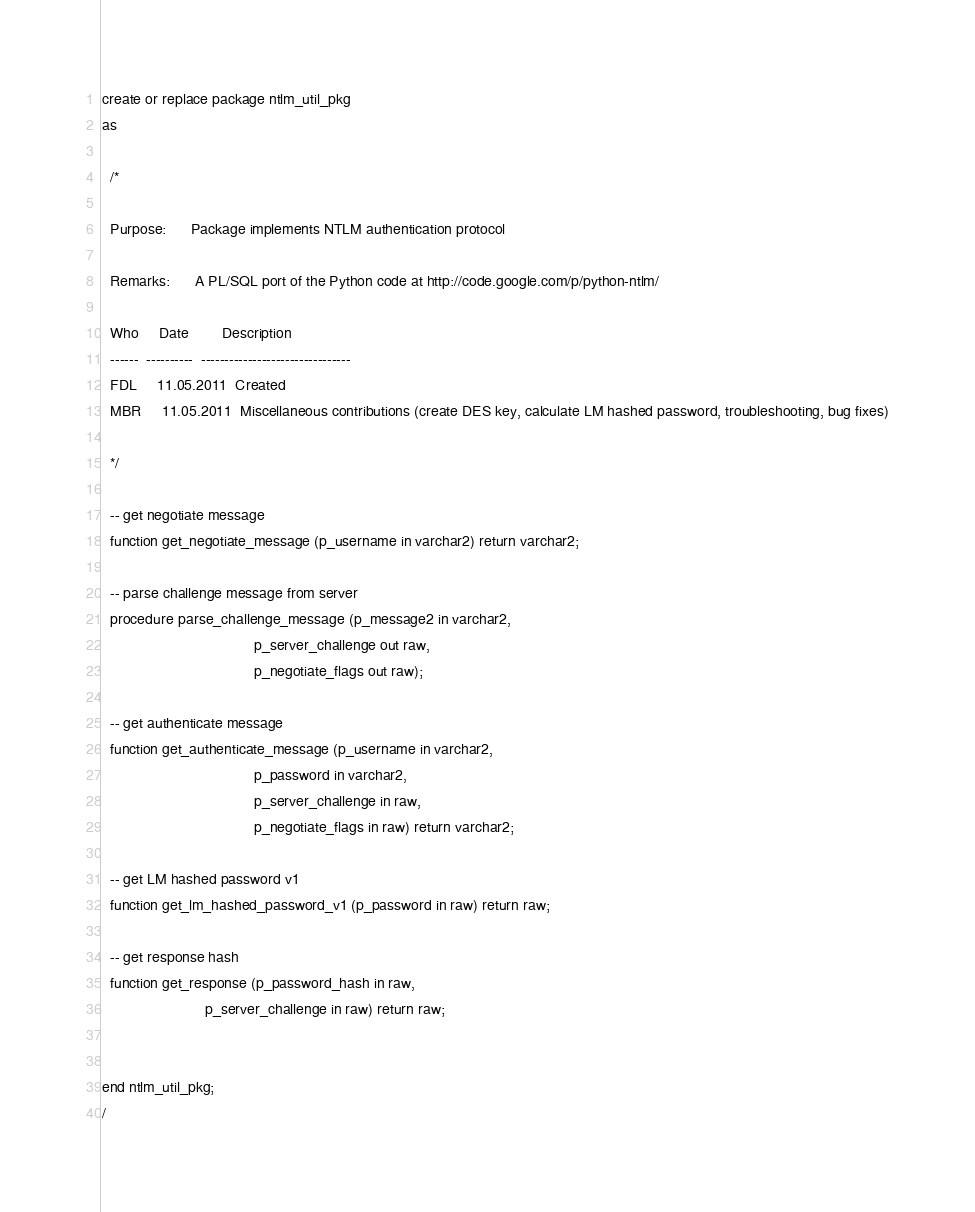Convert code to text. <code><loc_0><loc_0><loc_500><loc_500><_SQL_>create or replace package ntlm_util_pkg
as

  /*
 
  Purpose:      Package implements NTLM authentication protocol
 
  Remarks:      A PL/SQL port of the Python code at http://code.google.com/p/python-ntlm/
 
  Who     Date        Description
  ------  ----------  --------------------------------
  FDL     11.05.2011  Created
  MBR     11.05.2011  Miscellaneous contributions (create DES key, calculate LM hashed password, troubleshooting, bug fixes)
 
  */
  
  -- get negotiate message
  function get_negotiate_message (p_username in varchar2) return varchar2;

  -- parse challenge message from server                   
  procedure parse_challenge_message (p_message2 in varchar2,
                                     p_server_challenge out raw,
                                     p_negotiate_flags out raw);
                                     
  -- get authenticate message
  function get_authenticate_message (p_username in varchar2,
                                     p_password in varchar2,
                                     p_server_challenge in raw,
                                     p_negotiate_flags in raw) return varchar2;
                                     
  -- get LM hashed password v1
  function get_lm_hashed_password_v1 (p_password in raw) return raw;
  
  -- get response hash
  function get_response (p_password_hash in raw,
                         p_server_challenge in raw) return raw;


end ntlm_util_pkg;
/

</code> 